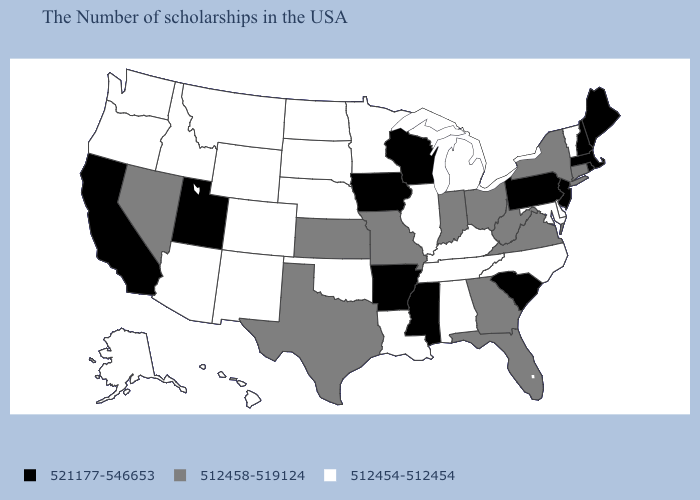Among the states that border Washington , which have the lowest value?
Give a very brief answer. Idaho, Oregon. Name the states that have a value in the range 521177-546653?
Quick response, please. Maine, Massachusetts, Rhode Island, New Hampshire, New Jersey, Pennsylvania, South Carolina, Wisconsin, Mississippi, Arkansas, Iowa, Utah, California. Does Vermont have the lowest value in the Northeast?
Give a very brief answer. Yes. Is the legend a continuous bar?
Write a very short answer. No. Name the states that have a value in the range 521177-546653?
Quick response, please. Maine, Massachusetts, Rhode Island, New Hampshire, New Jersey, Pennsylvania, South Carolina, Wisconsin, Mississippi, Arkansas, Iowa, Utah, California. Name the states that have a value in the range 512458-519124?
Quick response, please. Connecticut, New York, Virginia, West Virginia, Ohio, Florida, Georgia, Indiana, Missouri, Kansas, Texas, Nevada. Name the states that have a value in the range 512454-512454?
Concise answer only. Vermont, Delaware, Maryland, North Carolina, Michigan, Kentucky, Alabama, Tennessee, Illinois, Louisiana, Minnesota, Nebraska, Oklahoma, South Dakota, North Dakota, Wyoming, Colorado, New Mexico, Montana, Arizona, Idaho, Washington, Oregon, Alaska, Hawaii. Which states have the lowest value in the USA?
Short answer required. Vermont, Delaware, Maryland, North Carolina, Michigan, Kentucky, Alabama, Tennessee, Illinois, Louisiana, Minnesota, Nebraska, Oklahoma, South Dakota, North Dakota, Wyoming, Colorado, New Mexico, Montana, Arizona, Idaho, Washington, Oregon, Alaska, Hawaii. Name the states that have a value in the range 512454-512454?
Short answer required. Vermont, Delaware, Maryland, North Carolina, Michigan, Kentucky, Alabama, Tennessee, Illinois, Louisiana, Minnesota, Nebraska, Oklahoma, South Dakota, North Dakota, Wyoming, Colorado, New Mexico, Montana, Arizona, Idaho, Washington, Oregon, Alaska, Hawaii. Is the legend a continuous bar?
Concise answer only. No. Which states have the highest value in the USA?
Keep it brief. Maine, Massachusetts, Rhode Island, New Hampshire, New Jersey, Pennsylvania, South Carolina, Wisconsin, Mississippi, Arkansas, Iowa, Utah, California. Which states have the lowest value in the South?
Give a very brief answer. Delaware, Maryland, North Carolina, Kentucky, Alabama, Tennessee, Louisiana, Oklahoma. Name the states that have a value in the range 521177-546653?
Write a very short answer. Maine, Massachusetts, Rhode Island, New Hampshire, New Jersey, Pennsylvania, South Carolina, Wisconsin, Mississippi, Arkansas, Iowa, Utah, California. What is the value of West Virginia?
Give a very brief answer. 512458-519124. Does Virginia have a lower value than Idaho?
Quick response, please. No. 